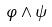Convert formula to latex. <formula><loc_0><loc_0><loc_500><loc_500>\varphi \wedge \psi</formula> 